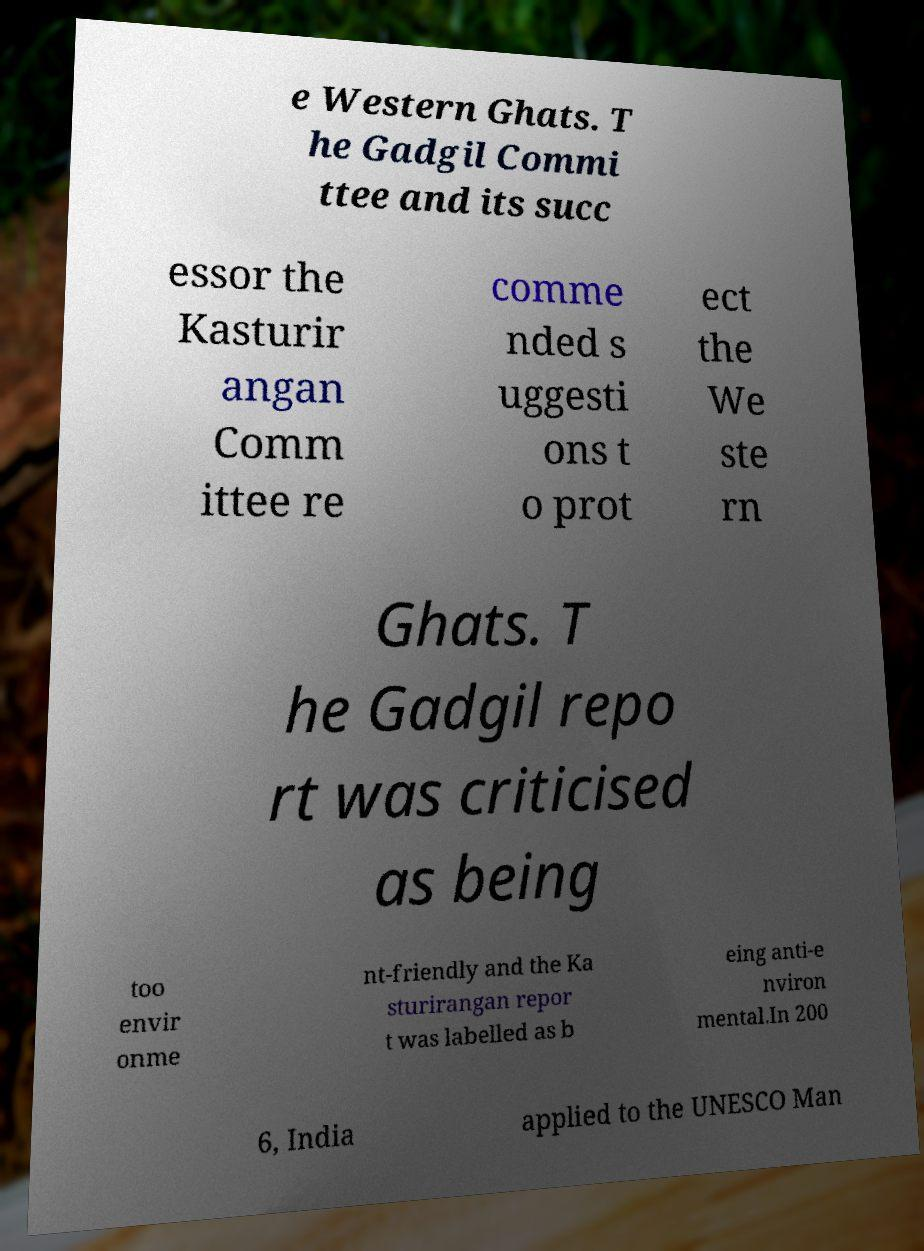Please read and relay the text visible in this image. What does it say? e Western Ghats. T he Gadgil Commi ttee and its succ essor the Kasturir angan Comm ittee re comme nded s uggesti ons t o prot ect the We ste rn Ghats. T he Gadgil repo rt was criticised as being too envir onme nt-friendly and the Ka sturirangan repor t was labelled as b eing anti-e nviron mental.In 200 6, India applied to the UNESCO Man 